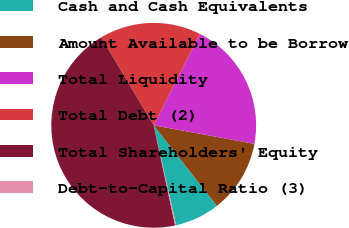Convert chart to OTSL. <chart><loc_0><loc_0><loc_500><loc_500><pie_chart><fcel>Cash and Cash Equivalents<fcel>Amount Available to be Borrow<fcel>Total Liquidity<fcel>Total Debt (2)<fcel>Total Shareholders' Equity<fcel>Debt-to-Capital Ratio (3)<nl><fcel>7.07%<fcel>11.53%<fcel>20.46%<fcel>15.99%<fcel>44.79%<fcel>0.16%<nl></chart> 